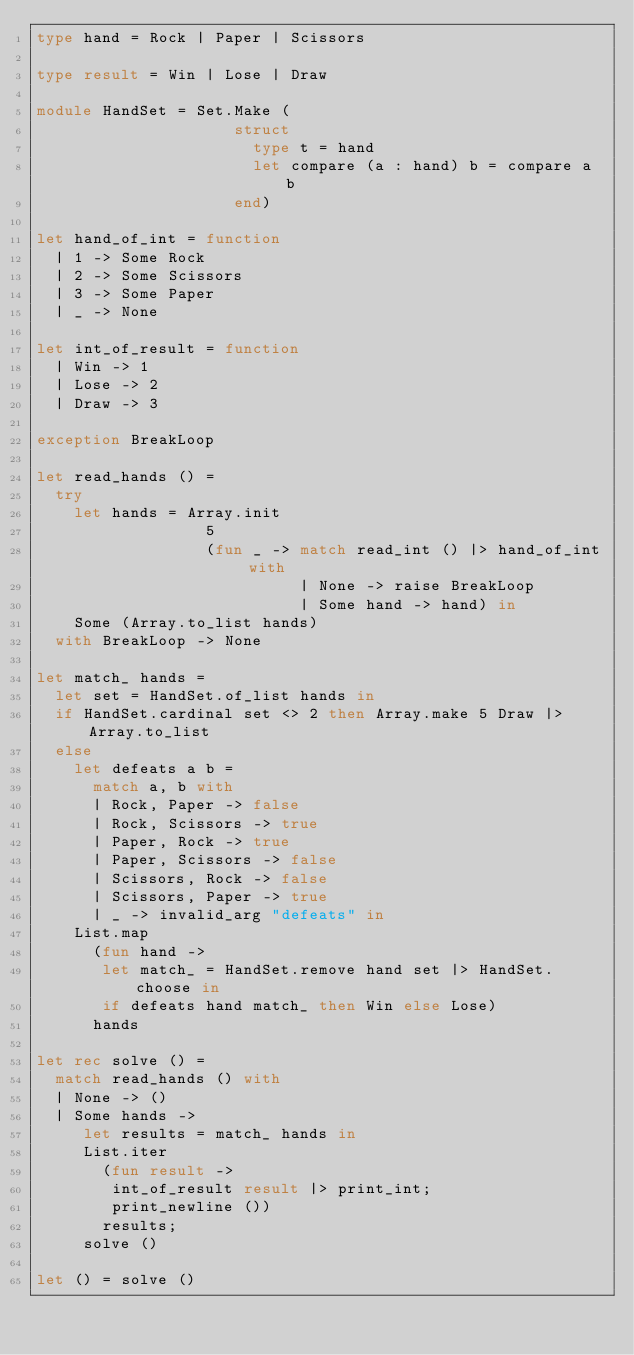Convert code to text. <code><loc_0><loc_0><loc_500><loc_500><_OCaml_>type hand = Rock | Paper | Scissors
 
type result = Win | Lose | Draw
 
module HandSet = Set.Make (
                     struct
                       type t = hand
                       let compare (a : hand) b = compare a b
                     end)
 
let hand_of_int = function
  | 1 -> Some Rock
  | 2 -> Some Scissors
  | 3 -> Some Paper
  | _ -> None
 
let int_of_result = function
  | Win -> 1
  | Lose -> 2
  | Draw -> 3
 
exception BreakLoop
 
let read_hands () =
  try
    let hands = Array.init
                  5
                  (fun _ -> match read_int () |> hand_of_int with
                            | None -> raise BreakLoop
                            | Some hand -> hand) in
    Some (Array.to_list hands)
  with BreakLoop -> None
 
let match_ hands =
  let set = HandSet.of_list hands in
  if HandSet.cardinal set <> 2 then Array.make 5 Draw |> Array.to_list
  else
    let defeats a b =
      match a, b with
      | Rock, Paper -> false
      | Rock, Scissors -> true
      | Paper, Rock -> true
      | Paper, Scissors -> false
      | Scissors, Rock -> false
      | Scissors, Paper -> true
      | _ -> invalid_arg "defeats" in
    List.map
      (fun hand ->
       let match_ = HandSet.remove hand set |> HandSet.choose in
       if defeats hand match_ then Win else Lose)
      hands
 
let rec solve () =
  match read_hands () with
  | None -> ()
  | Some hands ->
     let results = match_ hands in
     List.iter
       (fun result ->
        int_of_result result |> print_int;
        print_newline ())
       results;
     solve ()
 
let () = solve ()</code> 